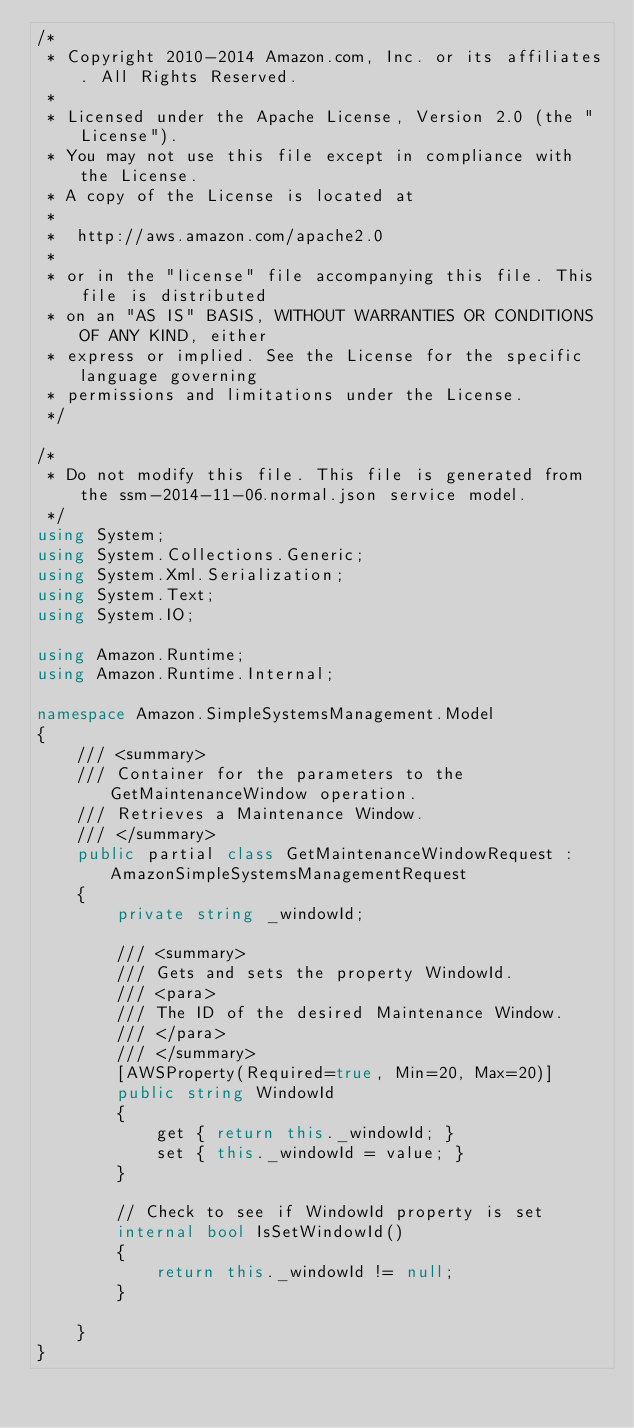<code> <loc_0><loc_0><loc_500><loc_500><_C#_>/*
 * Copyright 2010-2014 Amazon.com, Inc. or its affiliates. All Rights Reserved.
 * 
 * Licensed under the Apache License, Version 2.0 (the "License").
 * You may not use this file except in compliance with the License.
 * A copy of the License is located at
 * 
 *  http://aws.amazon.com/apache2.0
 * 
 * or in the "license" file accompanying this file. This file is distributed
 * on an "AS IS" BASIS, WITHOUT WARRANTIES OR CONDITIONS OF ANY KIND, either
 * express or implied. See the License for the specific language governing
 * permissions and limitations under the License.
 */

/*
 * Do not modify this file. This file is generated from the ssm-2014-11-06.normal.json service model.
 */
using System;
using System.Collections.Generic;
using System.Xml.Serialization;
using System.Text;
using System.IO;

using Amazon.Runtime;
using Amazon.Runtime.Internal;

namespace Amazon.SimpleSystemsManagement.Model
{
    /// <summary>
    /// Container for the parameters to the GetMaintenanceWindow operation.
    /// Retrieves a Maintenance Window.
    /// </summary>
    public partial class GetMaintenanceWindowRequest : AmazonSimpleSystemsManagementRequest
    {
        private string _windowId;

        /// <summary>
        /// Gets and sets the property WindowId. 
        /// <para>
        /// The ID of the desired Maintenance Window.
        /// </para>
        /// </summary>
        [AWSProperty(Required=true, Min=20, Max=20)]
        public string WindowId
        {
            get { return this._windowId; }
            set { this._windowId = value; }
        }

        // Check to see if WindowId property is set
        internal bool IsSetWindowId()
        {
            return this._windowId != null;
        }

    }
}</code> 